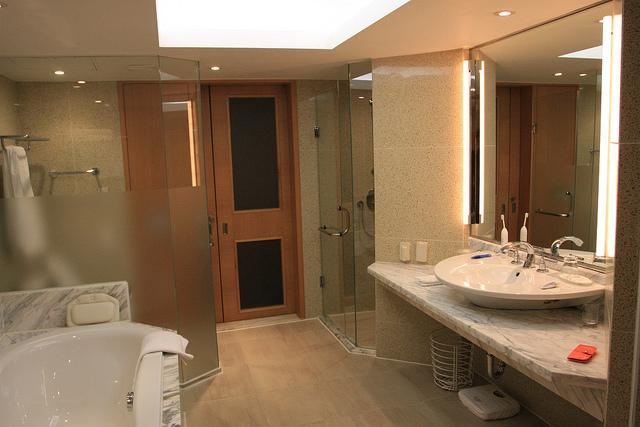What color is the little purse on the marble countertop next to the big raised sink? Please explain your reasoning. orange. The purse on the countertop is orange. 